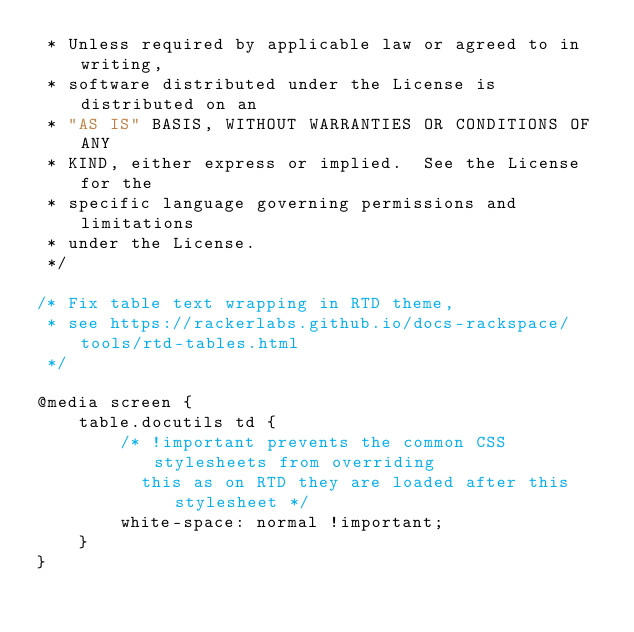Convert code to text. <code><loc_0><loc_0><loc_500><loc_500><_CSS_> * Unless required by applicable law or agreed to in writing,
 * software distributed under the License is distributed on an
 * "AS IS" BASIS, WITHOUT WARRANTIES OR CONDITIONS OF ANY
 * KIND, either express or implied.  See the License for the
 * specific language governing permissions and limitations
 * under the License.
 */

/* Fix table text wrapping in RTD theme,
 * see https://rackerlabs.github.io/docs-rackspace/tools/rtd-tables.html
 */

@media screen {
    table.docutils td {
        /* !important prevents the common CSS stylesheets from overriding
          this as on RTD they are loaded after this stylesheet */
        white-space: normal !important;
    }
}
</code> 